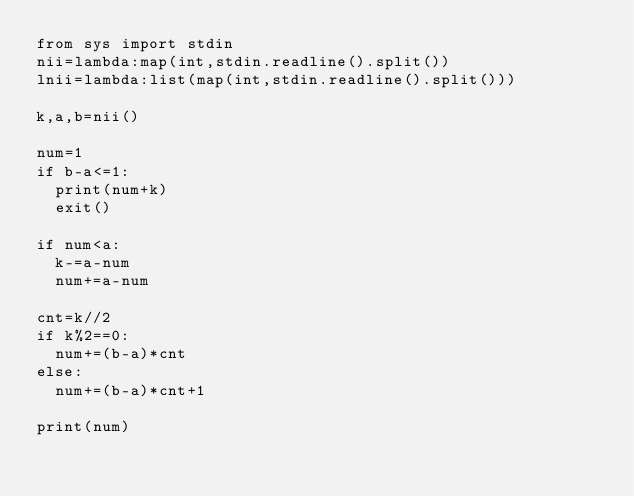Convert code to text. <code><loc_0><loc_0><loc_500><loc_500><_Python_>from sys import stdin
nii=lambda:map(int,stdin.readline().split())
lnii=lambda:list(map(int,stdin.readline().split()))

k,a,b=nii()

num=1
if b-a<=1:
  print(num+k)
  exit()

if num<a:
  k-=a-num
  num+=a-num

cnt=k//2
if k%2==0:
  num+=(b-a)*cnt
else:
  num+=(b-a)*cnt+1

print(num)</code> 